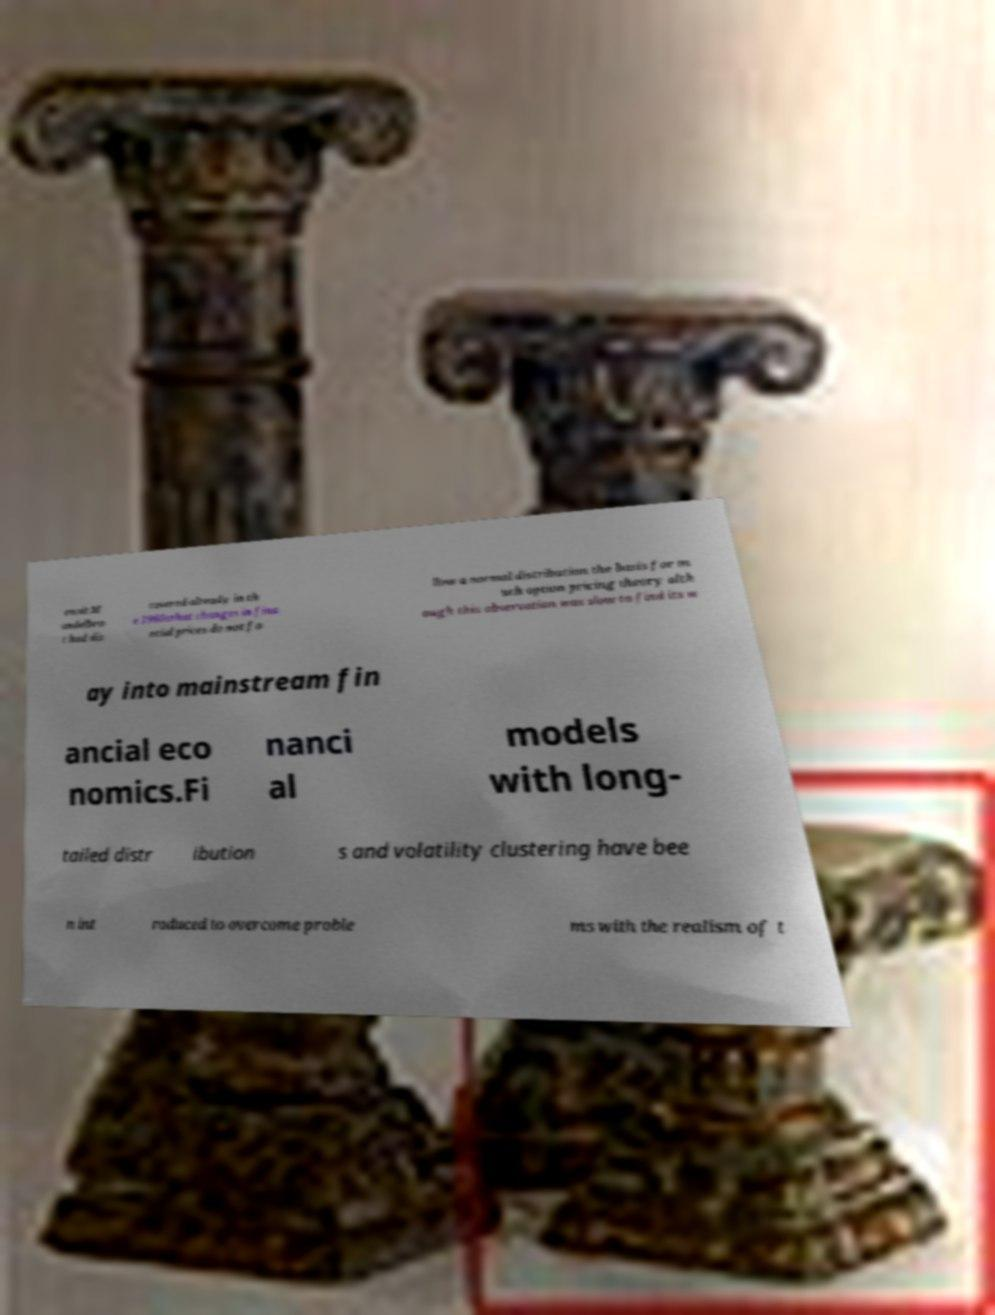What messages or text are displayed in this image? I need them in a readable, typed format. enoit M andelbro t had dis covered already in th e 1960sthat changes in fina ncial prices do not fo llow a normal distribution the basis for m uch option pricing theory alth ough this observation was slow to find its w ay into mainstream fin ancial eco nomics.Fi nanci al models with long- tailed distr ibution s and volatility clustering have bee n int roduced to overcome proble ms with the realism of t 